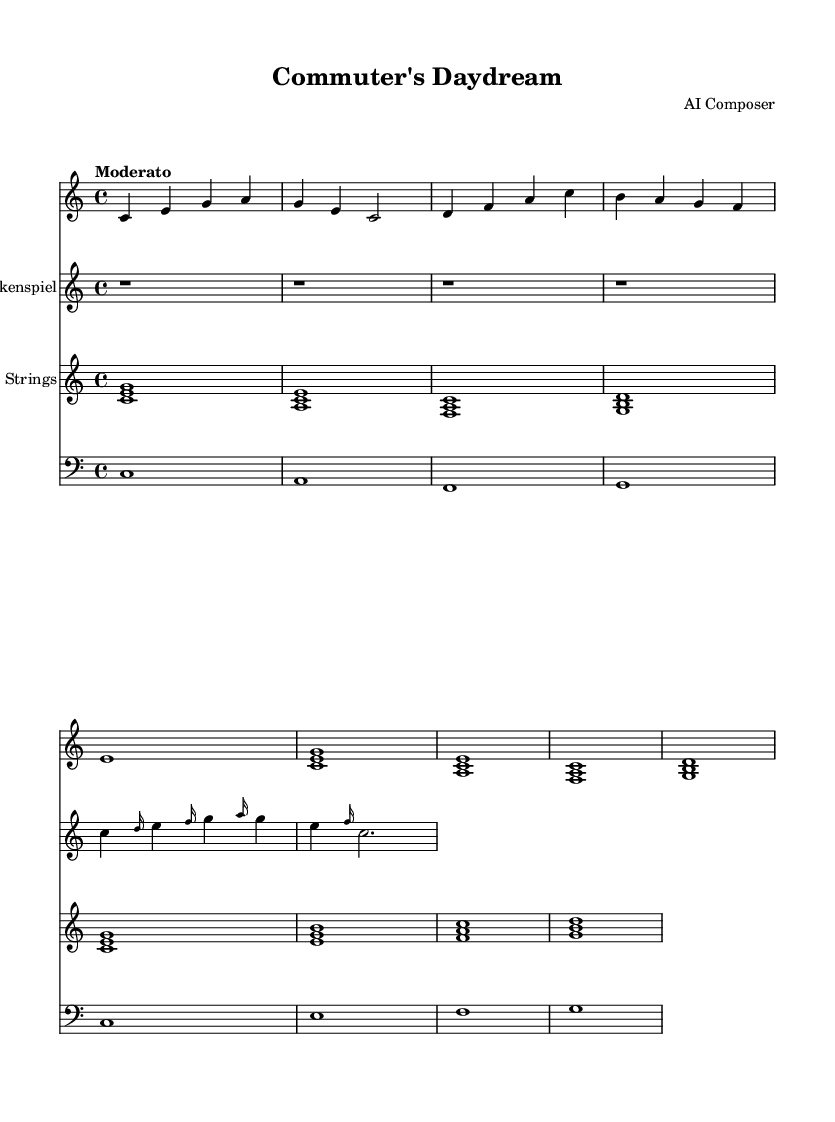What is the key signature of this music? The key signature is indicated at the beginning of the staff and it shows no sharps or flats, which denotes C major.
Answer: C major What is the time signature of this music? The time signature appears at the beginning of the staff and is represented as 4/4, meaning there are four beats in each measure and the quarter note gets one beat.
Answer: 4/4 What is the tempo marking of this music? The tempo marking is also found at the beginning of the score and states "Moderato," which implies a moderate pace for the piece.
Answer: Moderato How many measures does the piano part contain? To find the number of measures, we can count the segments between the bar lines in the piano part, leading us to a total of 8 measures.
Answer: 8 Which instruments are indicated in the score? The score lists four instruments: Piano, Glockenspiel, Strings, and Bass. Each instrument is shown with a separate staff, and their names are labeled at the start of each staff.
Answer: Piano, Glockenspiel, Strings, Bass What is the rhythm pattern in the glockenspiel part? By analyzing the glockenspiel part, we notice that all notes begin after a rest, and then the rhythm emphasizes short notes followed by a longer note, overall creating a consistent rhythmic pattern.
Answer: Rest followed by short notes and a long note How does the harmonic progression of the strings part function? The strings part shows a sequence of triads in harmonic motion, specifically using chords built on the root notes C, A, F, and G, establishing a tonal center that supports the melody in the piano and glockenspiel.
Answer: Uses triads on C, A, F, and G 